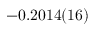<formula> <loc_0><loc_0><loc_500><loc_500>- 0 . 2 0 1 4 ( 1 6 )</formula> 